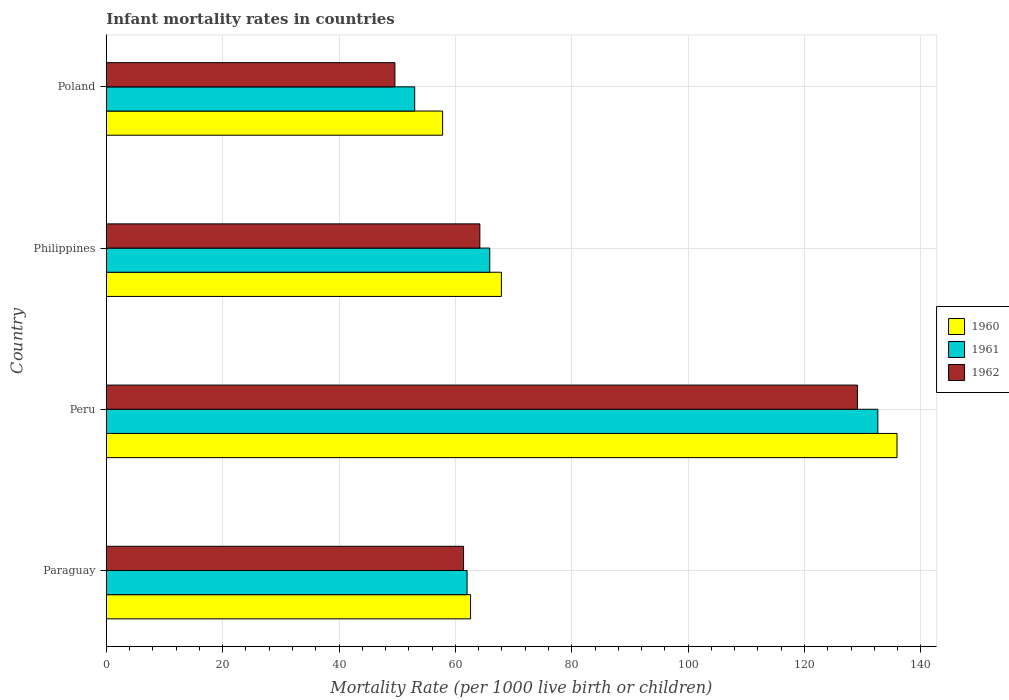How many different coloured bars are there?
Provide a succinct answer. 3. Are the number of bars per tick equal to the number of legend labels?
Your answer should be compact. Yes. Are the number of bars on each tick of the Y-axis equal?
Ensure brevity in your answer.  Yes. How many bars are there on the 3rd tick from the top?
Keep it short and to the point. 3. In how many cases, is the number of bars for a given country not equal to the number of legend labels?
Ensure brevity in your answer.  0. What is the infant mortality rate in 1962 in Philippines?
Provide a short and direct response. 64.2. Across all countries, what is the maximum infant mortality rate in 1960?
Ensure brevity in your answer.  135.9. Across all countries, what is the minimum infant mortality rate in 1961?
Your answer should be very brief. 53. In which country was the infant mortality rate in 1960 maximum?
Make the answer very short. Peru. What is the total infant mortality rate in 1960 in the graph?
Your response must be concise. 324.2. What is the difference between the infant mortality rate in 1962 in Paraguay and that in Philippines?
Provide a short and direct response. -2.8. What is the difference between the infant mortality rate in 1960 in Poland and the infant mortality rate in 1961 in Philippines?
Offer a terse response. -8.1. What is the average infant mortality rate in 1961 per country?
Make the answer very short. 78.38. What is the difference between the infant mortality rate in 1960 and infant mortality rate in 1962 in Peru?
Give a very brief answer. 6.8. What is the ratio of the infant mortality rate in 1962 in Paraguay to that in Poland?
Provide a short and direct response. 1.24. Is the infant mortality rate in 1961 in Paraguay less than that in Poland?
Give a very brief answer. No. Is the difference between the infant mortality rate in 1960 in Paraguay and Poland greater than the difference between the infant mortality rate in 1962 in Paraguay and Poland?
Your answer should be compact. No. What is the difference between the highest and the lowest infant mortality rate in 1961?
Ensure brevity in your answer.  79.6. Is the sum of the infant mortality rate in 1962 in Paraguay and Philippines greater than the maximum infant mortality rate in 1960 across all countries?
Ensure brevity in your answer.  No. Are all the bars in the graph horizontal?
Your answer should be very brief. Yes. How many countries are there in the graph?
Make the answer very short. 4. Where does the legend appear in the graph?
Provide a succinct answer. Center right. How many legend labels are there?
Your response must be concise. 3. What is the title of the graph?
Provide a succinct answer. Infant mortality rates in countries. What is the label or title of the X-axis?
Your answer should be compact. Mortality Rate (per 1000 live birth or children). What is the Mortality Rate (per 1000 live birth or children) in 1960 in Paraguay?
Provide a succinct answer. 62.6. What is the Mortality Rate (per 1000 live birth or children) of 1962 in Paraguay?
Provide a short and direct response. 61.4. What is the Mortality Rate (per 1000 live birth or children) in 1960 in Peru?
Ensure brevity in your answer.  135.9. What is the Mortality Rate (per 1000 live birth or children) in 1961 in Peru?
Provide a succinct answer. 132.6. What is the Mortality Rate (per 1000 live birth or children) in 1962 in Peru?
Ensure brevity in your answer.  129.1. What is the Mortality Rate (per 1000 live birth or children) in 1960 in Philippines?
Offer a terse response. 67.9. What is the Mortality Rate (per 1000 live birth or children) of 1961 in Philippines?
Offer a terse response. 65.9. What is the Mortality Rate (per 1000 live birth or children) in 1962 in Philippines?
Make the answer very short. 64.2. What is the Mortality Rate (per 1000 live birth or children) in 1960 in Poland?
Offer a terse response. 57.8. What is the Mortality Rate (per 1000 live birth or children) of 1961 in Poland?
Provide a short and direct response. 53. What is the Mortality Rate (per 1000 live birth or children) in 1962 in Poland?
Offer a very short reply. 49.6. Across all countries, what is the maximum Mortality Rate (per 1000 live birth or children) in 1960?
Give a very brief answer. 135.9. Across all countries, what is the maximum Mortality Rate (per 1000 live birth or children) of 1961?
Make the answer very short. 132.6. Across all countries, what is the maximum Mortality Rate (per 1000 live birth or children) in 1962?
Provide a succinct answer. 129.1. Across all countries, what is the minimum Mortality Rate (per 1000 live birth or children) of 1960?
Your answer should be compact. 57.8. Across all countries, what is the minimum Mortality Rate (per 1000 live birth or children) of 1962?
Make the answer very short. 49.6. What is the total Mortality Rate (per 1000 live birth or children) of 1960 in the graph?
Provide a short and direct response. 324.2. What is the total Mortality Rate (per 1000 live birth or children) of 1961 in the graph?
Your response must be concise. 313.5. What is the total Mortality Rate (per 1000 live birth or children) of 1962 in the graph?
Make the answer very short. 304.3. What is the difference between the Mortality Rate (per 1000 live birth or children) of 1960 in Paraguay and that in Peru?
Offer a terse response. -73.3. What is the difference between the Mortality Rate (per 1000 live birth or children) of 1961 in Paraguay and that in Peru?
Give a very brief answer. -70.6. What is the difference between the Mortality Rate (per 1000 live birth or children) of 1962 in Paraguay and that in Peru?
Give a very brief answer. -67.7. What is the difference between the Mortality Rate (per 1000 live birth or children) in 1960 in Paraguay and that in Philippines?
Provide a succinct answer. -5.3. What is the difference between the Mortality Rate (per 1000 live birth or children) of 1961 in Paraguay and that in Philippines?
Offer a very short reply. -3.9. What is the difference between the Mortality Rate (per 1000 live birth or children) in 1960 in Paraguay and that in Poland?
Offer a very short reply. 4.8. What is the difference between the Mortality Rate (per 1000 live birth or children) in 1960 in Peru and that in Philippines?
Offer a terse response. 68. What is the difference between the Mortality Rate (per 1000 live birth or children) in 1961 in Peru and that in Philippines?
Make the answer very short. 66.7. What is the difference between the Mortality Rate (per 1000 live birth or children) of 1962 in Peru and that in Philippines?
Provide a succinct answer. 64.9. What is the difference between the Mortality Rate (per 1000 live birth or children) in 1960 in Peru and that in Poland?
Give a very brief answer. 78.1. What is the difference between the Mortality Rate (per 1000 live birth or children) of 1961 in Peru and that in Poland?
Ensure brevity in your answer.  79.6. What is the difference between the Mortality Rate (per 1000 live birth or children) in 1962 in Peru and that in Poland?
Provide a succinct answer. 79.5. What is the difference between the Mortality Rate (per 1000 live birth or children) in 1960 in Paraguay and the Mortality Rate (per 1000 live birth or children) in 1961 in Peru?
Your answer should be very brief. -70. What is the difference between the Mortality Rate (per 1000 live birth or children) in 1960 in Paraguay and the Mortality Rate (per 1000 live birth or children) in 1962 in Peru?
Your answer should be very brief. -66.5. What is the difference between the Mortality Rate (per 1000 live birth or children) of 1961 in Paraguay and the Mortality Rate (per 1000 live birth or children) of 1962 in Peru?
Provide a succinct answer. -67.1. What is the difference between the Mortality Rate (per 1000 live birth or children) of 1960 in Paraguay and the Mortality Rate (per 1000 live birth or children) of 1961 in Philippines?
Offer a terse response. -3.3. What is the difference between the Mortality Rate (per 1000 live birth or children) of 1960 in Paraguay and the Mortality Rate (per 1000 live birth or children) of 1962 in Philippines?
Provide a short and direct response. -1.6. What is the difference between the Mortality Rate (per 1000 live birth or children) in 1960 in Paraguay and the Mortality Rate (per 1000 live birth or children) in 1961 in Poland?
Make the answer very short. 9.6. What is the difference between the Mortality Rate (per 1000 live birth or children) of 1960 in Paraguay and the Mortality Rate (per 1000 live birth or children) of 1962 in Poland?
Offer a terse response. 13. What is the difference between the Mortality Rate (per 1000 live birth or children) in 1960 in Peru and the Mortality Rate (per 1000 live birth or children) in 1962 in Philippines?
Keep it short and to the point. 71.7. What is the difference between the Mortality Rate (per 1000 live birth or children) in 1961 in Peru and the Mortality Rate (per 1000 live birth or children) in 1962 in Philippines?
Your response must be concise. 68.4. What is the difference between the Mortality Rate (per 1000 live birth or children) in 1960 in Peru and the Mortality Rate (per 1000 live birth or children) in 1961 in Poland?
Give a very brief answer. 82.9. What is the difference between the Mortality Rate (per 1000 live birth or children) in 1960 in Peru and the Mortality Rate (per 1000 live birth or children) in 1962 in Poland?
Give a very brief answer. 86.3. What is the difference between the Mortality Rate (per 1000 live birth or children) in 1961 in Peru and the Mortality Rate (per 1000 live birth or children) in 1962 in Poland?
Keep it short and to the point. 83. What is the difference between the Mortality Rate (per 1000 live birth or children) in 1960 in Philippines and the Mortality Rate (per 1000 live birth or children) in 1961 in Poland?
Provide a succinct answer. 14.9. What is the difference between the Mortality Rate (per 1000 live birth or children) in 1961 in Philippines and the Mortality Rate (per 1000 live birth or children) in 1962 in Poland?
Make the answer very short. 16.3. What is the average Mortality Rate (per 1000 live birth or children) in 1960 per country?
Your response must be concise. 81.05. What is the average Mortality Rate (per 1000 live birth or children) of 1961 per country?
Your answer should be very brief. 78.38. What is the average Mortality Rate (per 1000 live birth or children) of 1962 per country?
Ensure brevity in your answer.  76.08. What is the difference between the Mortality Rate (per 1000 live birth or children) of 1960 and Mortality Rate (per 1000 live birth or children) of 1962 in Paraguay?
Make the answer very short. 1.2. What is the difference between the Mortality Rate (per 1000 live birth or children) of 1961 and Mortality Rate (per 1000 live birth or children) of 1962 in Paraguay?
Your answer should be very brief. 0.6. What is the difference between the Mortality Rate (per 1000 live birth or children) in 1961 and Mortality Rate (per 1000 live birth or children) in 1962 in Peru?
Keep it short and to the point. 3.5. What is the difference between the Mortality Rate (per 1000 live birth or children) of 1960 and Mortality Rate (per 1000 live birth or children) of 1961 in Philippines?
Your answer should be compact. 2. What is the difference between the Mortality Rate (per 1000 live birth or children) of 1961 and Mortality Rate (per 1000 live birth or children) of 1962 in Philippines?
Your response must be concise. 1.7. What is the ratio of the Mortality Rate (per 1000 live birth or children) of 1960 in Paraguay to that in Peru?
Offer a very short reply. 0.46. What is the ratio of the Mortality Rate (per 1000 live birth or children) of 1961 in Paraguay to that in Peru?
Your answer should be compact. 0.47. What is the ratio of the Mortality Rate (per 1000 live birth or children) of 1962 in Paraguay to that in Peru?
Keep it short and to the point. 0.48. What is the ratio of the Mortality Rate (per 1000 live birth or children) of 1960 in Paraguay to that in Philippines?
Keep it short and to the point. 0.92. What is the ratio of the Mortality Rate (per 1000 live birth or children) of 1961 in Paraguay to that in Philippines?
Give a very brief answer. 0.94. What is the ratio of the Mortality Rate (per 1000 live birth or children) of 1962 in Paraguay to that in Philippines?
Offer a terse response. 0.96. What is the ratio of the Mortality Rate (per 1000 live birth or children) in 1960 in Paraguay to that in Poland?
Provide a succinct answer. 1.08. What is the ratio of the Mortality Rate (per 1000 live birth or children) in 1961 in Paraguay to that in Poland?
Provide a short and direct response. 1.17. What is the ratio of the Mortality Rate (per 1000 live birth or children) of 1962 in Paraguay to that in Poland?
Offer a terse response. 1.24. What is the ratio of the Mortality Rate (per 1000 live birth or children) of 1960 in Peru to that in Philippines?
Your answer should be compact. 2. What is the ratio of the Mortality Rate (per 1000 live birth or children) of 1961 in Peru to that in Philippines?
Provide a short and direct response. 2.01. What is the ratio of the Mortality Rate (per 1000 live birth or children) of 1962 in Peru to that in Philippines?
Your answer should be compact. 2.01. What is the ratio of the Mortality Rate (per 1000 live birth or children) of 1960 in Peru to that in Poland?
Ensure brevity in your answer.  2.35. What is the ratio of the Mortality Rate (per 1000 live birth or children) in 1961 in Peru to that in Poland?
Make the answer very short. 2.5. What is the ratio of the Mortality Rate (per 1000 live birth or children) of 1962 in Peru to that in Poland?
Offer a very short reply. 2.6. What is the ratio of the Mortality Rate (per 1000 live birth or children) in 1960 in Philippines to that in Poland?
Give a very brief answer. 1.17. What is the ratio of the Mortality Rate (per 1000 live birth or children) in 1961 in Philippines to that in Poland?
Your answer should be very brief. 1.24. What is the ratio of the Mortality Rate (per 1000 live birth or children) of 1962 in Philippines to that in Poland?
Make the answer very short. 1.29. What is the difference between the highest and the second highest Mortality Rate (per 1000 live birth or children) in 1961?
Your response must be concise. 66.7. What is the difference between the highest and the second highest Mortality Rate (per 1000 live birth or children) in 1962?
Provide a short and direct response. 64.9. What is the difference between the highest and the lowest Mortality Rate (per 1000 live birth or children) in 1960?
Provide a succinct answer. 78.1. What is the difference between the highest and the lowest Mortality Rate (per 1000 live birth or children) of 1961?
Keep it short and to the point. 79.6. What is the difference between the highest and the lowest Mortality Rate (per 1000 live birth or children) of 1962?
Ensure brevity in your answer.  79.5. 